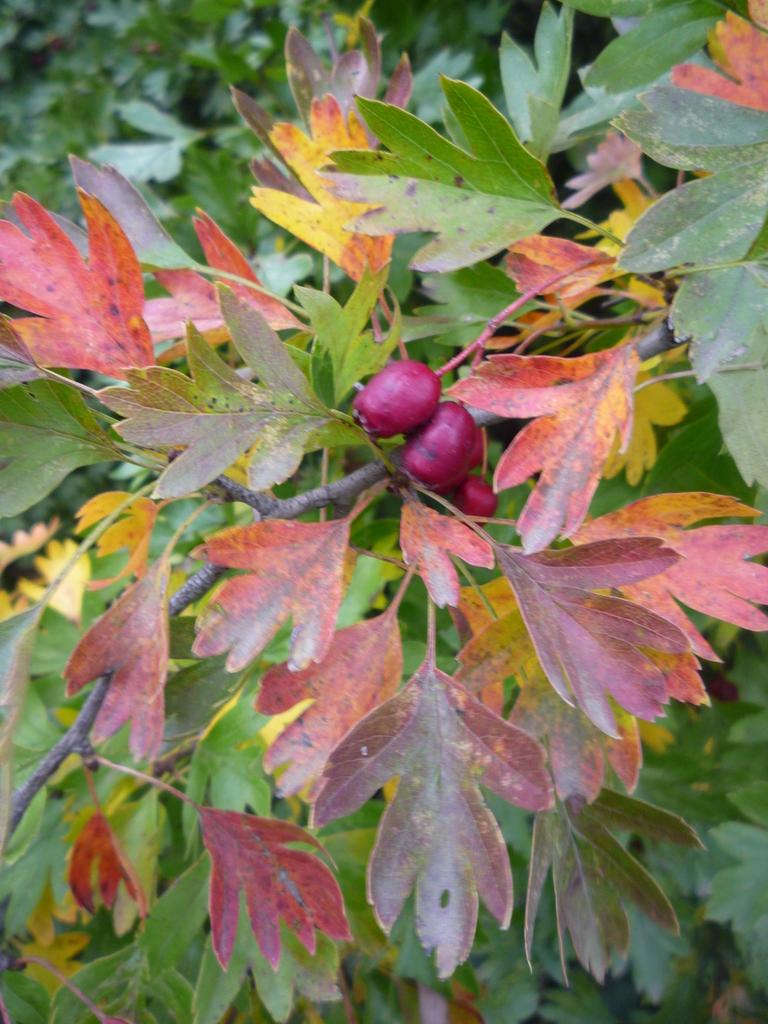What is the main subject of the image? The main subject of the image is a branch of a tree. What can be observed on the branch? The branch has leaves and fruits. What else can be seen in the background of the image? There are leaves visible in the background. How much sugar is present on the branch in the image? There is no sugar present on the branch in the image; it has fruits and leaves. What type of thread can be seen connecting the leaves in the image? There is no thread connecting the leaves in the image; the leaves are naturally attached to the branch. 